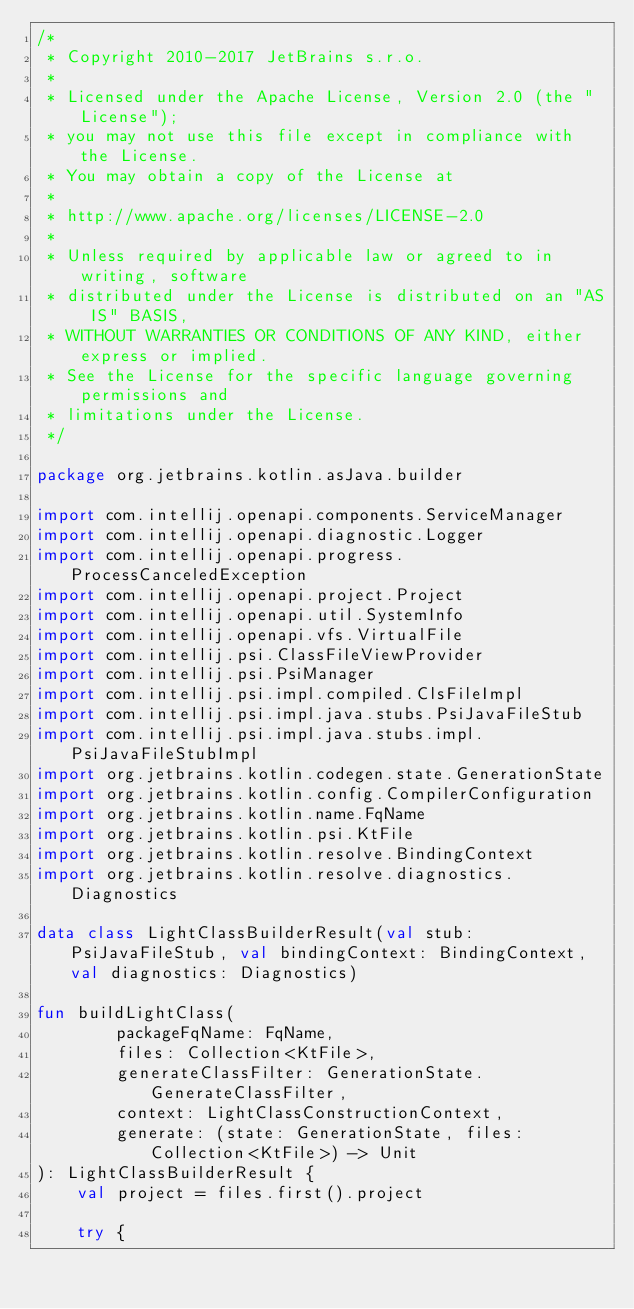Convert code to text. <code><loc_0><loc_0><loc_500><loc_500><_Kotlin_>/*
 * Copyright 2010-2017 JetBrains s.r.o.
 *
 * Licensed under the Apache License, Version 2.0 (the "License");
 * you may not use this file except in compliance with the License.
 * You may obtain a copy of the License at
 *
 * http://www.apache.org/licenses/LICENSE-2.0
 *
 * Unless required by applicable law or agreed to in writing, software
 * distributed under the License is distributed on an "AS IS" BASIS,
 * WITHOUT WARRANTIES OR CONDITIONS OF ANY KIND, either express or implied.
 * See the License for the specific language governing permissions and
 * limitations under the License.
 */

package org.jetbrains.kotlin.asJava.builder

import com.intellij.openapi.components.ServiceManager
import com.intellij.openapi.diagnostic.Logger
import com.intellij.openapi.progress.ProcessCanceledException
import com.intellij.openapi.project.Project
import com.intellij.openapi.util.SystemInfo
import com.intellij.openapi.vfs.VirtualFile
import com.intellij.psi.ClassFileViewProvider
import com.intellij.psi.PsiManager
import com.intellij.psi.impl.compiled.ClsFileImpl
import com.intellij.psi.impl.java.stubs.PsiJavaFileStub
import com.intellij.psi.impl.java.stubs.impl.PsiJavaFileStubImpl
import org.jetbrains.kotlin.codegen.state.GenerationState
import org.jetbrains.kotlin.config.CompilerConfiguration
import org.jetbrains.kotlin.name.FqName
import org.jetbrains.kotlin.psi.KtFile
import org.jetbrains.kotlin.resolve.BindingContext
import org.jetbrains.kotlin.resolve.diagnostics.Diagnostics

data class LightClassBuilderResult(val stub: PsiJavaFileStub, val bindingContext: BindingContext, val diagnostics: Diagnostics)

fun buildLightClass(
        packageFqName: FqName,
        files: Collection<KtFile>,
        generateClassFilter: GenerationState.GenerateClassFilter,
        context: LightClassConstructionContext,
        generate: (state: GenerationState, files: Collection<KtFile>) -> Unit
): LightClassBuilderResult {
    val project = files.first().project

    try {</code> 